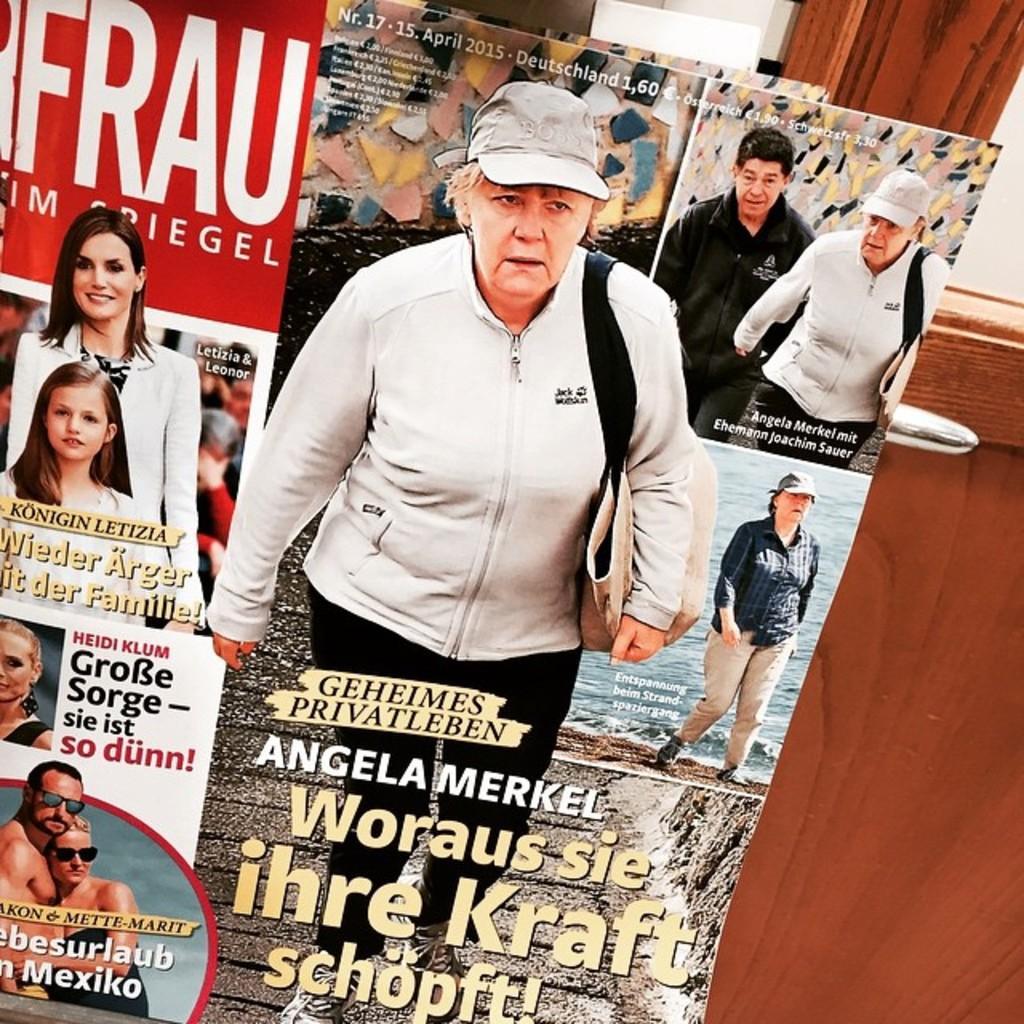Describe this image in one or two sentences. There is a magazine cover page in the image, the page covers few persons and a text on it. There is a wooden door at the right side of the image. 